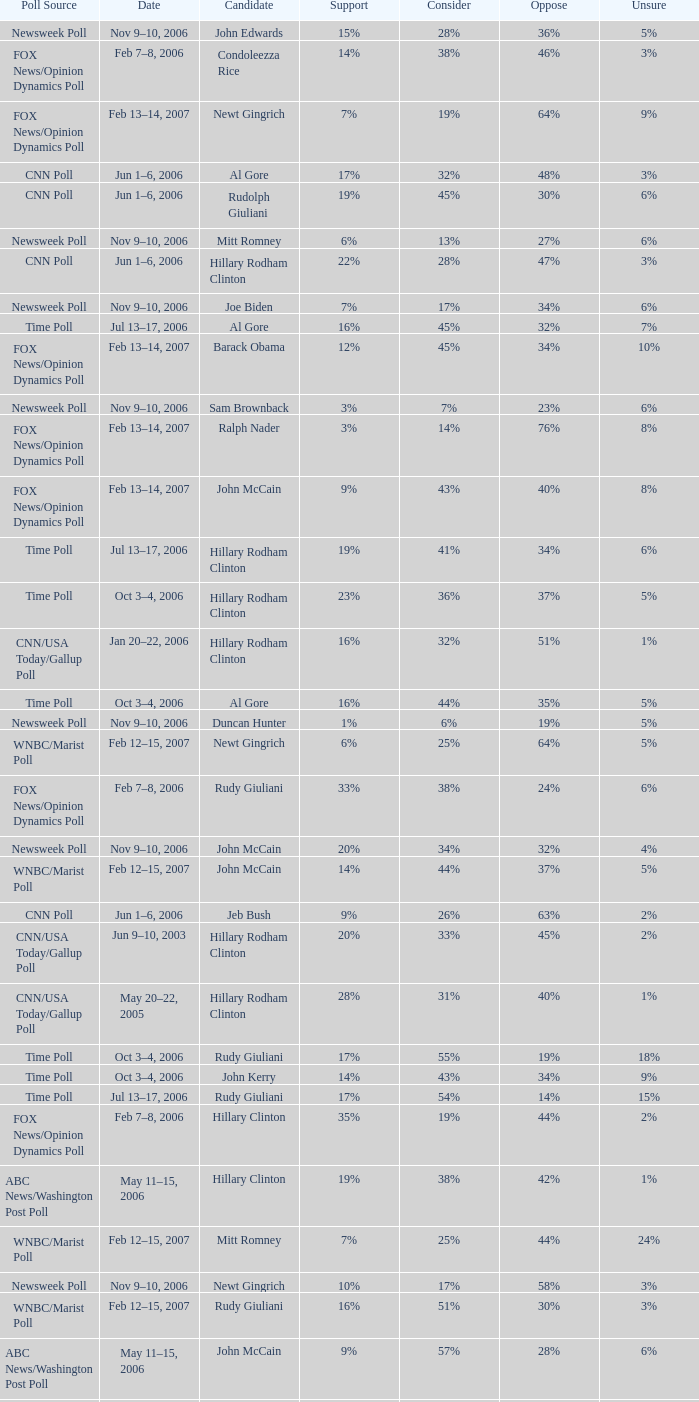What percentage of people said they would consider Rudy Giuliani as a candidate according to the Newsweek poll that showed 32% opposed him? 30%. 